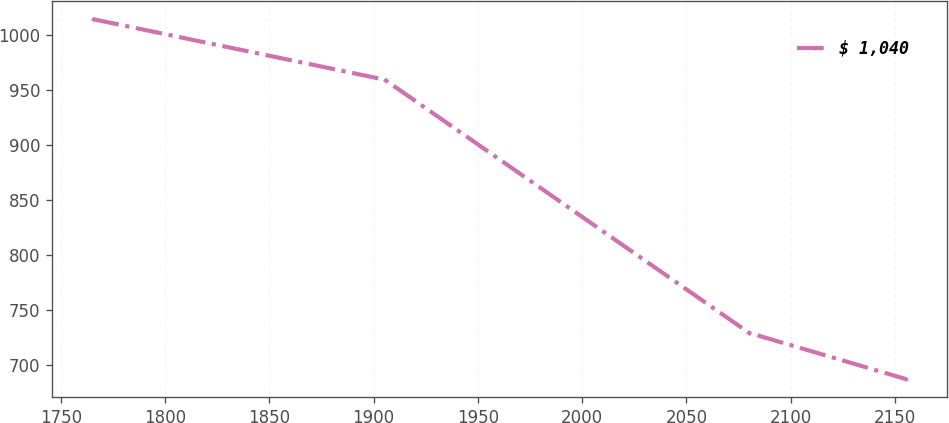<chart> <loc_0><loc_0><loc_500><loc_500><line_chart><ecel><fcel>$ 1,040<nl><fcel>1765.18<fcel>1014.36<nl><fcel>1905.31<fcel>959.29<nl><fcel>2080.06<fcel>729.04<nl><fcel>2155.58<fcel>686.89<nl></chart> 